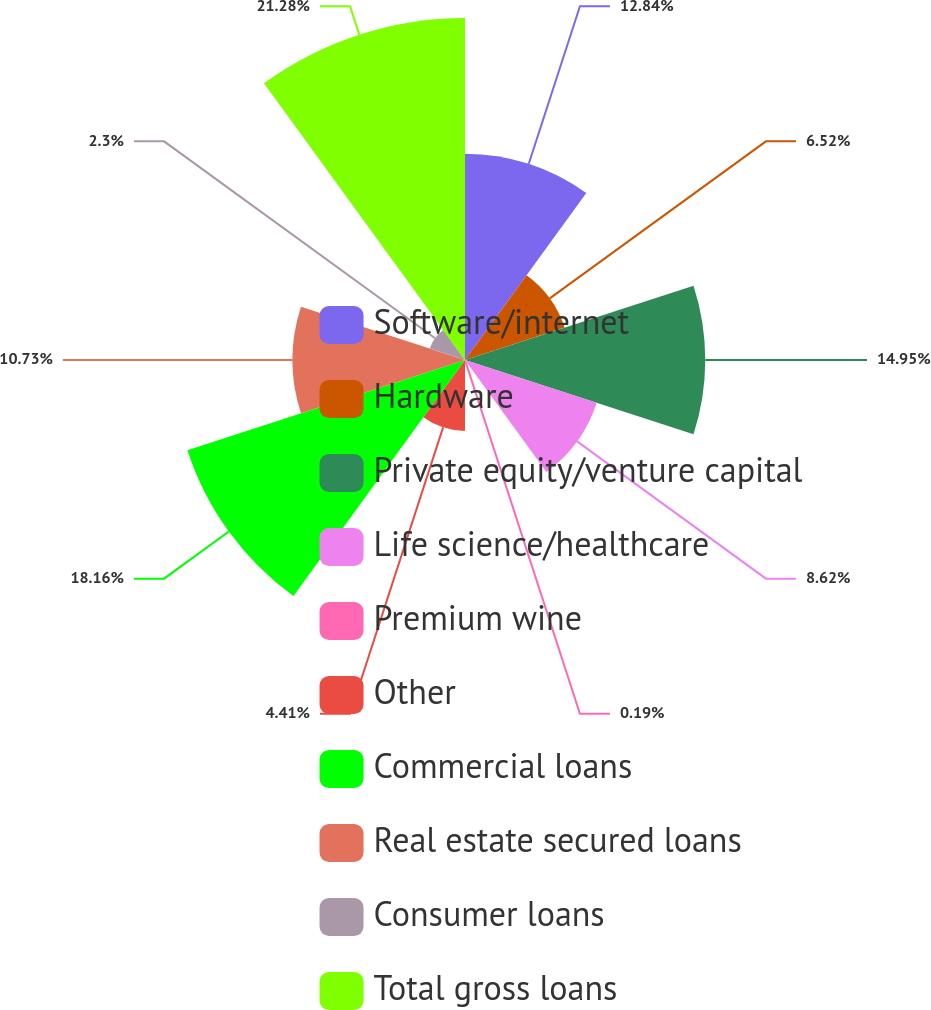Convert chart. <chart><loc_0><loc_0><loc_500><loc_500><pie_chart><fcel>Software/internet<fcel>Hardware<fcel>Private equity/venture capital<fcel>Life science/healthcare<fcel>Premium wine<fcel>Other<fcel>Commercial loans<fcel>Real estate secured loans<fcel>Consumer loans<fcel>Total gross loans<nl><fcel>12.84%<fcel>6.52%<fcel>14.95%<fcel>8.62%<fcel>0.19%<fcel>4.41%<fcel>18.16%<fcel>10.73%<fcel>2.3%<fcel>21.28%<nl></chart> 